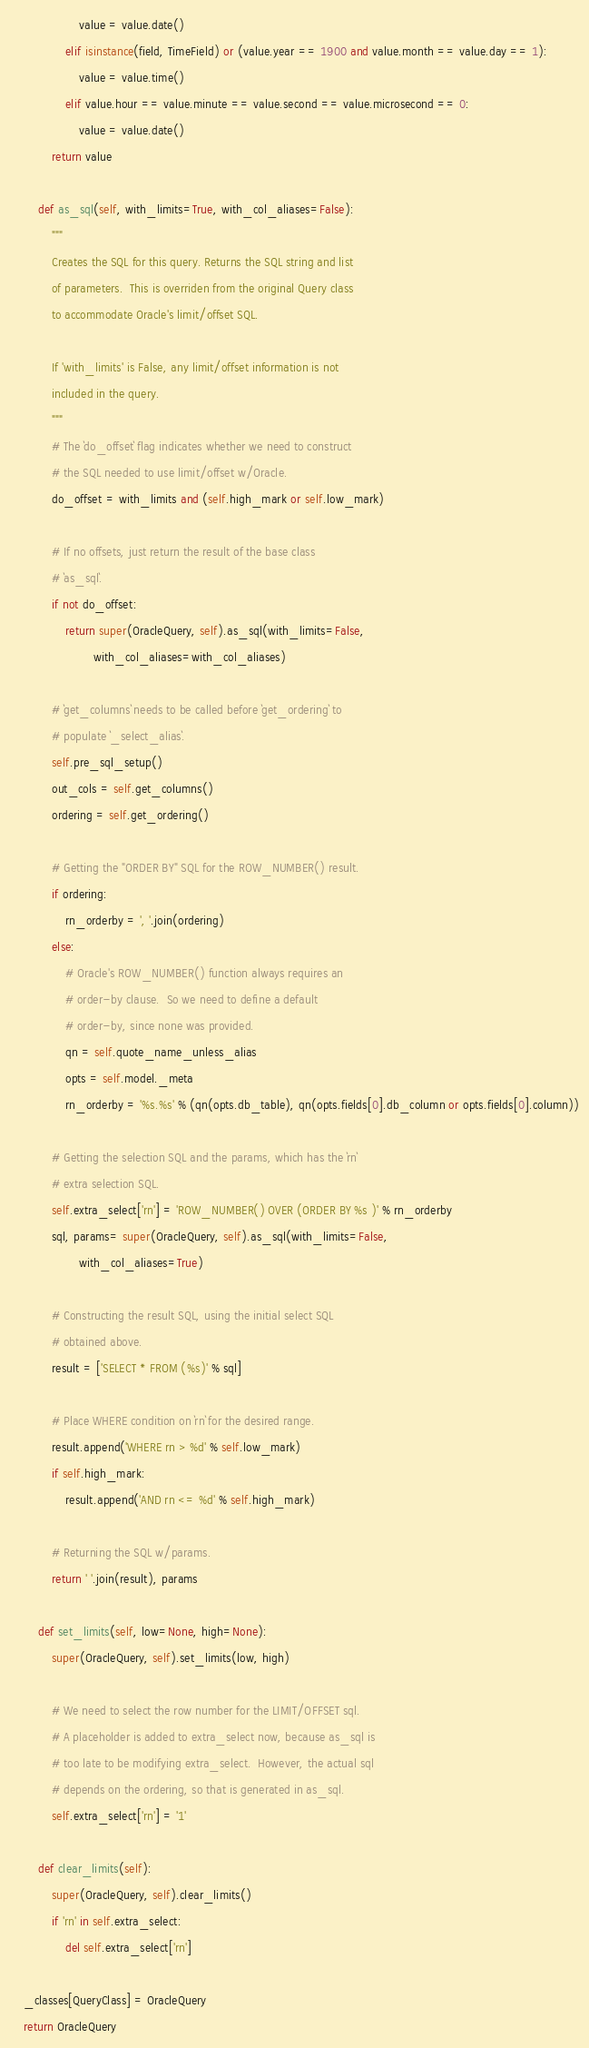<code> <loc_0><loc_0><loc_500><loc_500><_Python_>                    value = value.date()
                elif isinstance(field, TimeField) or (value.year == 1900 and value.month == value.day == 1):
                    value = value.time()
                elif value.hour == value.minute == value.second == value.microsecond == 0:
                    value = value.date()
            return value

        def as_sql(self, with_limits=True, with_col_aliases=False):
            """
            Creates the SQL for this query. Returns the SQL string and list
            of parameters.  This is overriden from the original Query class
            to accommodate Oracle's limit/offset SQL.

            If 'with_limits' is False, any limit/offset information is not
            included in the query.
            """
            # The `do_offset` flag indicates whether we need to construct
            # the SQL needed to use limit/offset w/Oracle.
            do_offset = with_limits and (self.high_mark or self.low_mark)

            # If no offsets, just return the result of the base class
            # `as_sql`.
            if not do_offset:
                return super(OracleQuery, self).as_sql(with_limits=False,
                        with_col_aliases=with_col_aliases)

            # `get_columns` needs to be called before `get_ordering` to
            # populate `_select_alias`.
            self.pre_sql_setup()
            out_cols = self.get_columns()
            ordering = self.get_ordering()

            # Getting the "ORDER BY" SQL for the ROW_NUMBER() result.
            if ordering:
                rn_orderby = ', '.join(ordering)
            else:
                # Oracle's ROW_NUMBER() function always requires an
                # order-by clause.  So we need to define a default
                # order-by, since none was provided.
                qn = self.quote_name_unless_alias
                opts = self.model._meta
                rn_orderby = '%s.%s' % (qn(opts.db_table), qn(opts.fields[0].db_column or opts.fields[0].column))

            # Getting the selection SQL and the params, which has the `rn`
            # extra selection SQL.
            self.extra_select['rn'] = 'ROW_NUMBER() OVER (ORDER BY %s )' % rn_orderby
            sql, params= super(OracleQuery, self).as_sql(with_limits=False,
                    with_col_aliases=True)

            # Constructing the result SQL, using the initial select SQL
            # obtained above.
            result = ['SELECT * FROM (%s)' % sql]

            # Place WHERE condition on `rn` for the desired range.
            result.append('WHERE rn > %d' % self.low_mark)
            if self.high_mark:
                result.append('AND rn <= %d' % self.high_mark)

            # Returning the SQL w/params.
            return ' '.join(result), params

        def set_limits(self, low=None, high=None):
            super(OracleQuery, self).set_limits(low, high)

            # We need to select the row number for the LIMIT/OFFSET sql.
            # A placeholder is added to extra_select now, because as_sql is
            # too late to be modifying extra_select.  However, the actual sql
            # depends on the ordering, so that is generated in as_sql.
            self.extra_select['rn'] = '1'

        def clear_limits(self):
            super(OracleQuery, self).clear_limits()
            if 'rn' in self.extra_select:
                del self.extra_select['rn']

    _classes[QueryClass] = OracleQuery
    return OracleQuery

</code> 